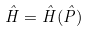<formula> <loc_0><loc_0><loc_500><loc_500>\hat { H } = \hat { H } ( \hat { P } )</formula> 